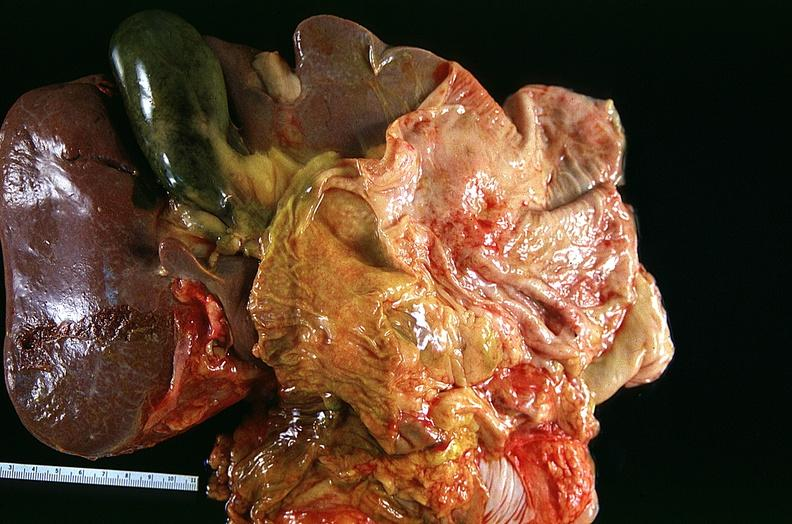what is present?
Answer the question using a single word or phrase. Respiratory 